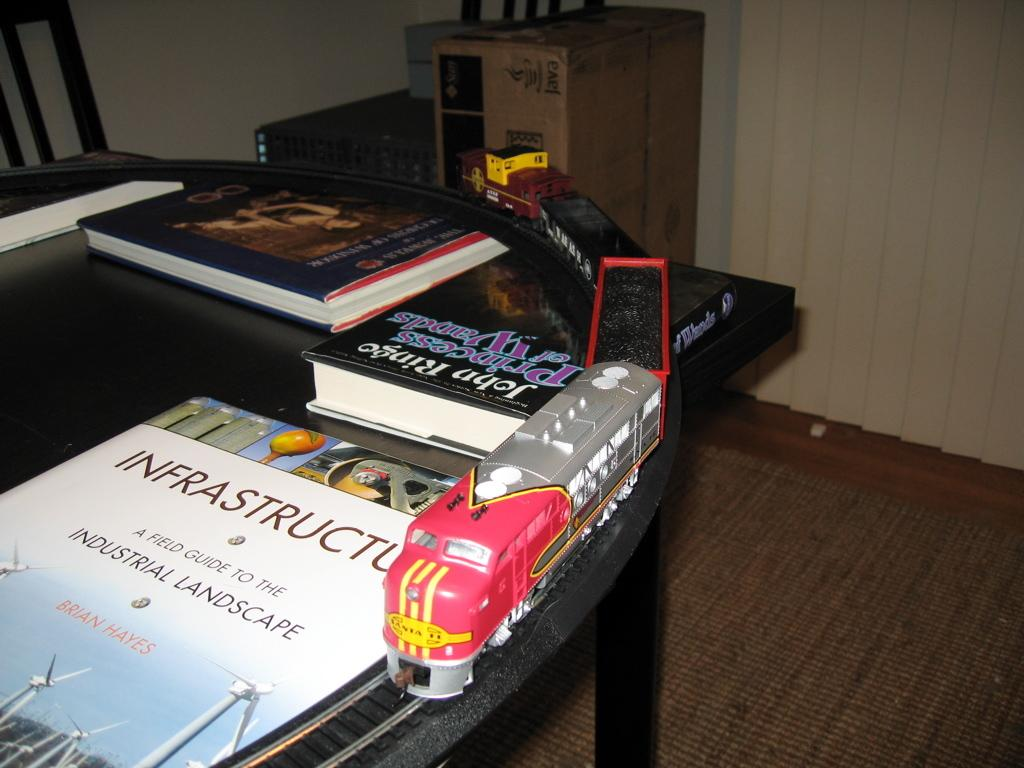<image>
Create a compact narrative representing the image presented. A model train sits next to a book about infrastructure. 